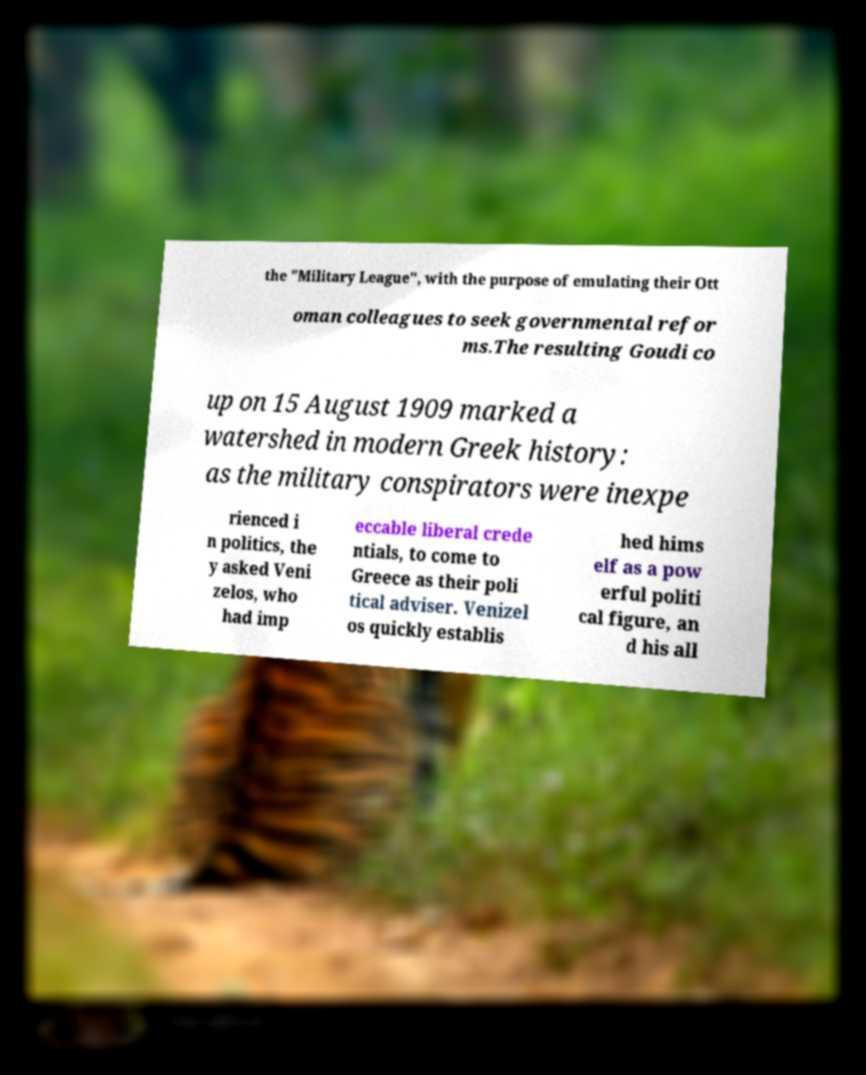There's text embedded in this image that I need extracted. Can you transcribe it verbatim? the "Military League", with the purpose of emulating their Ott oman colleagues to seek governmental refor ms.The resulting Goudi co up on 15 August 1909 marked a watershed in modern Greek history: as the military conspirators were inexpe rienced i n politics, the y asked Veni zelos, who had imp eccable liberal crede ntials, to come to Greece as their poli tical adviser. Venizel os quickly establis hed hims elf as a pow erful politi cal figure, an d his all 